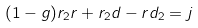<formula> <loc_0><loc_0><loc_500><loc_500>( 1 - g ) r _ { 2 } r + r _ { 2 } d - r d _ { 2 } = j</formula> 